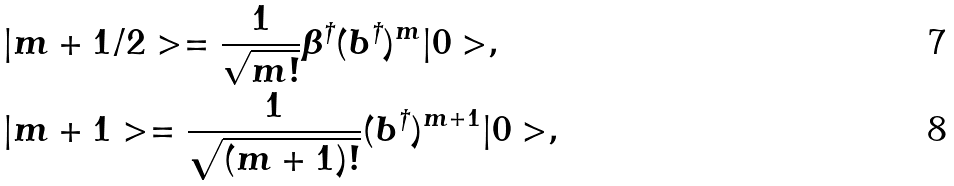Convert formula to latex. <formula><loc_0><loc_0><loc_500><loc_500>& | m + { 1 } / { 2 } > = \frac { 1 } { \sqrt { m ! } } \beta ^ { \dagger } ( b ^ { \dagger } ) ^ { m } | 0 > , \\ & | m + 1 > = \frac { 1 } { \sqrt { ( m + 1 ) ! } } ( b ^ { \dagger } ) ^ { m + 1 } | 0 > ,</formula> 